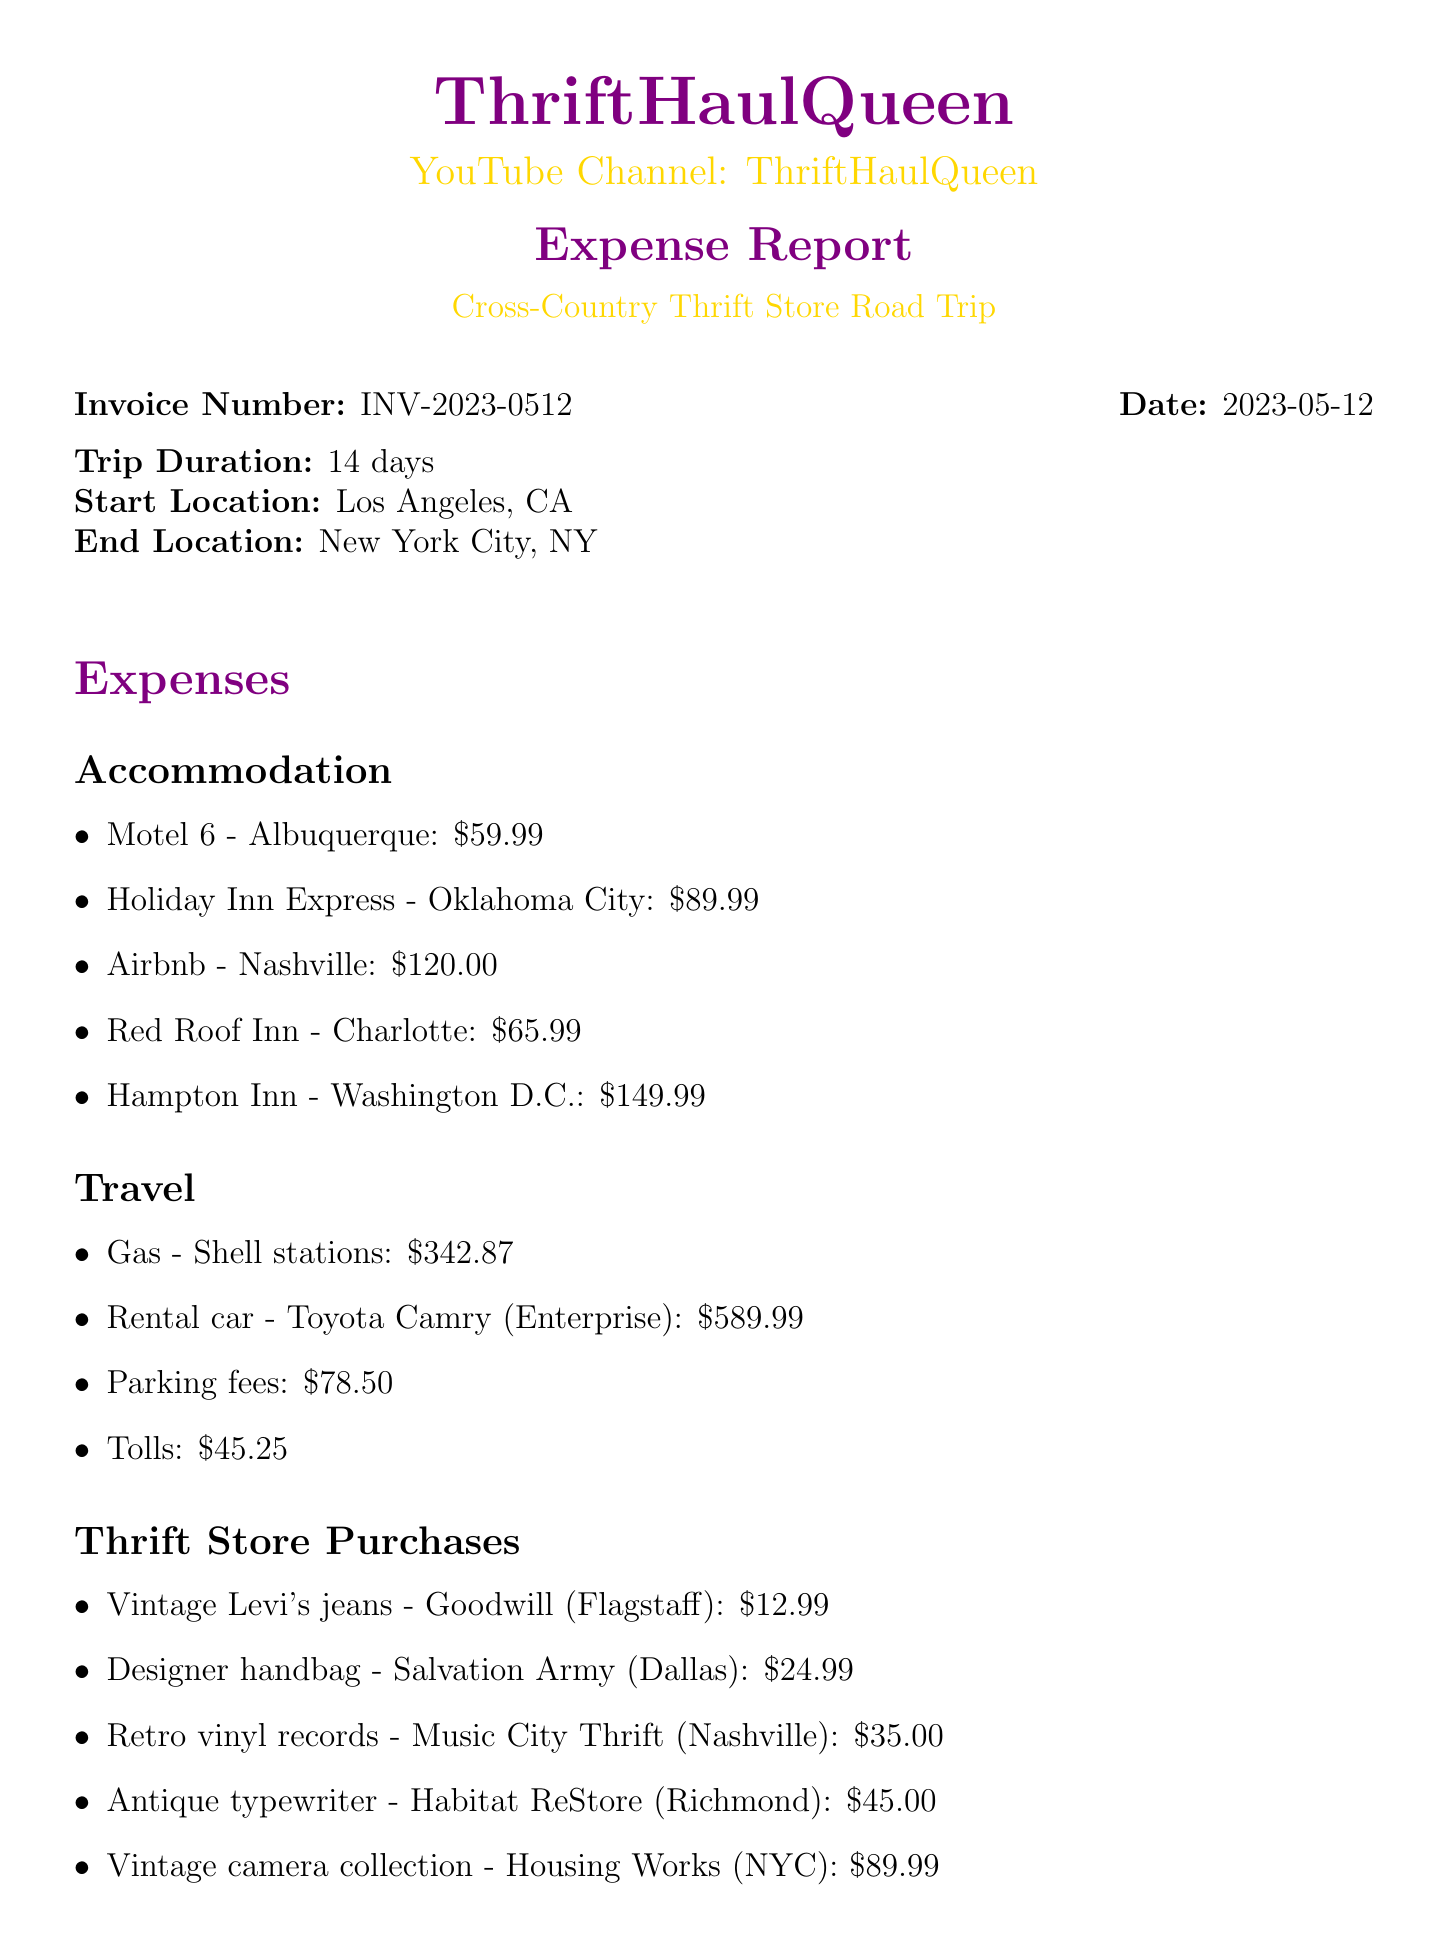What is the invoice number? The invoice number is clearly listed in the document as a unique identifier, which is INV-2023-0512.
Answer: INV-2023-0512 What was the start location of the trip? The start location is specified in the document, indicating where the road trip began, which is Los Angeles, CA.
Answer: Los Angeles, CA How many days did the trip last? The trip duration is noted, providing the length of the trip in days, which is 14 days.
Answer: 14 days What is the total expense amount? The total expenses summarize the financial details of the trip, listed at the end of the document as a single figure, which is $2,455.26.
Answer: $2,455.26 Which thrift store purchase cost the most? By comparing all listed thrift store items, the item with the highest cost is found, which is the vintage camera collection for $89.99.
Answer: Vintage camera collection - Housing Works (NYC) What are the travel expenses for parking fees? The document outlines specific costs under the travel category, with parking fees listed as a separate item costing $78.50.
Answer: $78.50 How much did the rental car cost? The rental car expense is explicitly stated in the travel section of the document, which is $589.99 for a Toyota Camry.
Answer: $589.99 What category did the vintage Levi's jeans fall under? The document organizes expenses into categories, and the vintage Levi's jeans are listed under thrift store purchases.
Answer: Thrift Store Purchases What note is included regarding travel expenses? The document includes a note explaining that travel expenses are deductible as business expenses for content creation purposes.
Answer: Travel expenses are deductible as business expenses for content creation purposes 